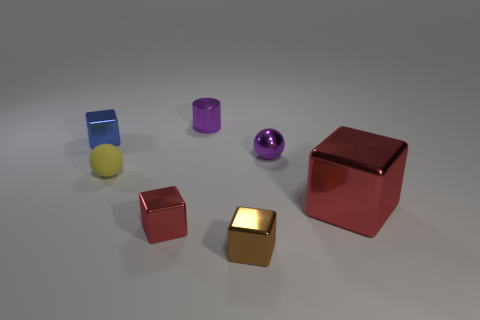Add 3 big red objects. How many objects exist? 10 Subtract all blocks. How many objects are left? 3 Subtract all large blue matte cylinders. Subtract all yellow balls. How many objects are left? 6 Add 2 tiny metal cubes. How many tiny metal cubes are left? 5 Add 7 blue metal things. How many blue metal things exist? 8 Subtract 0 cyan cubes. How many objects are left? 7 